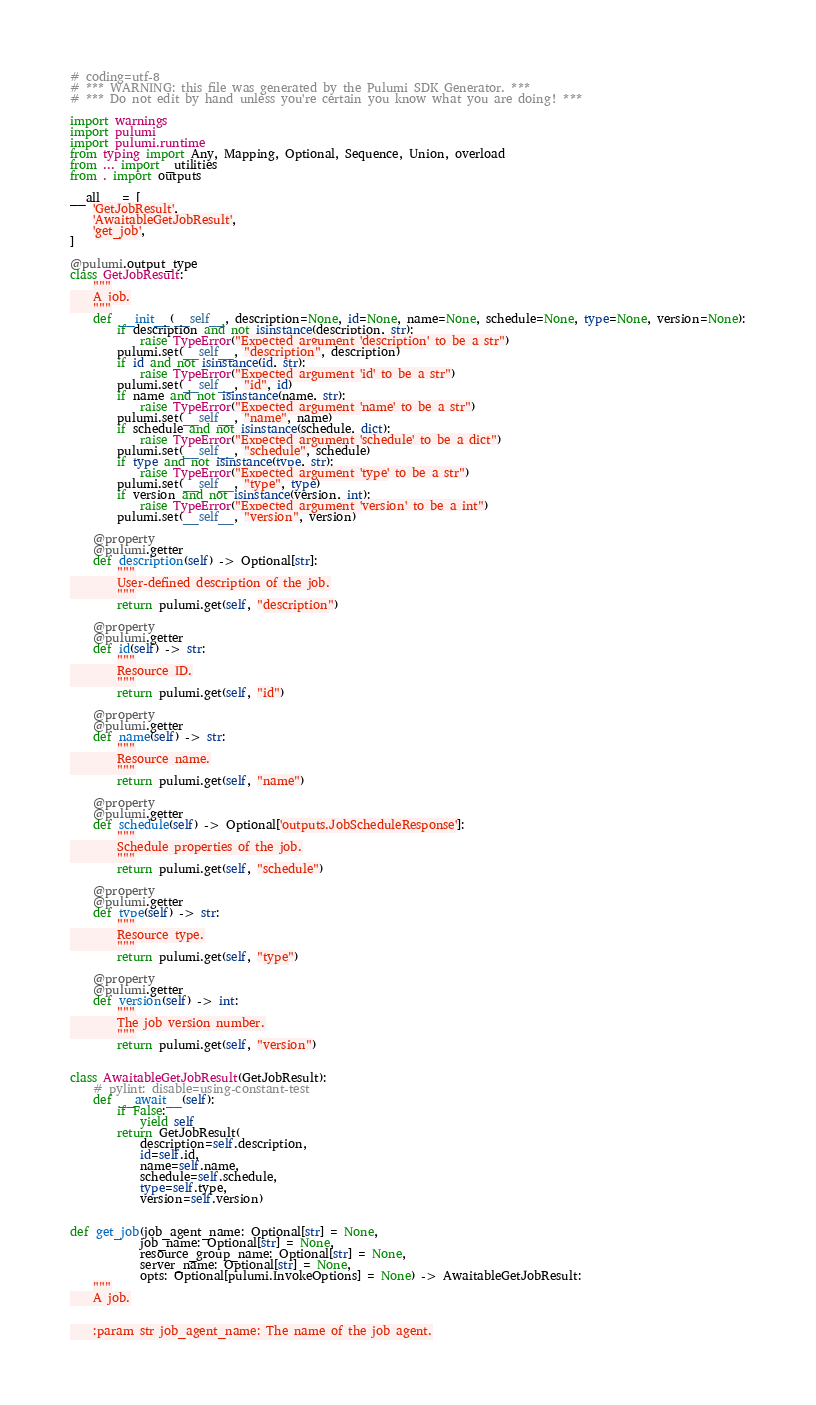Convert code to text. <code><loc_0><loc_0><loc_500><loc_500><_Python_># coding=utf-8
# *** WARNING: this file was generated by the Pulumi SDK Generator. ***
# *** Do not edit by hand unless you're certain you know what you are doing! ***

import warnings
import pulumi
import pulumi.runtime
from typing import Any, Mapping, Optional, Sequence, Union, overload
from ... import _utilities
from . import outputs

__all__ = [
    'GetJobResult',
    'AwaitableGetJobResult',
    'get_job',
]

@pulumi.output_type
class GetJobResult:
    """
    A job.
    """
    def __init__(__self__, description=None, id=None, name=None, schedule=None, type=None, version=None):
        if description and not isinstance(description, str):
            raise TypeError("Expected argument 'description' to be a str")
        pulumi.set(__self__, "description", description)
        if id and not isinstance(id, str):
            raise TypeError("Expected argument 'id' to be a str")
        pulumi.set(__self__, "id", id)
        if name and not isinstance(name, str):
            raise TypeError("Expected argument 'name' to be a str")
        pulumi.set(__self__, "name", name)
        if schedule and not isinstance(schedule, dict):
            raise TypeError("Expected argument 'schedule' to be a dict")
        pulumi.set(__self__, "schedule", schedule)
        if type and not isinstance(type, str):
            raise TypeError("Expected argument 'type' to be a str")
        pulumi.set(__self__, "type", type)
        if version and not isinstance(version, int):
            raise TypeError("Expected argument 'version' to be a int")
        pulumi.set(__self__, "version", version)

    @property
    @pulumi.getter
    def description(self) -> Optional[str]:
        """
        User-defined description of the job.
        """
        return pulumi.get(self, "description")

    @property
    @pulumi.getter
    def id(self) -> str:
        """
        Resource ID.
        """
        return pulumi.get(self, "id")

    @property
    @pulumi.getter
    def name(self) -> str:
        """
        Resource name.
        """
        return pulumi.get(self, "name")

    @property
    @pulumi.getter
    def schedule(self) -> Optional['outputs.JobScheduleResponse']:
        """
        Schedule properties of the job.
        """
        return pulumi.get(self, "schedule")

    @property
    @pulumi.getter
    def type(self) -> str:
        """
        Resource type.
        """
        return pulumi.get(self, "type")

    @property
    @pulumi.getter
    def version(self) -> int:
        """
        The job version number.
        """
        return pulumi.get(self, "version")


class AwaitableGetJobResult(GetJobResult):
    # pylint: disable=using-constant-test
    def __await__(self):
        if False:
            yield self
        return GetJobResult(
            description=self.description,
            id=self.id,
            name=self.name,
            schedule=self.schedule,
            type=self.type,
            version=self.version)


def get_job(job_agent_name: Optional[str] = None,
            job_name: Optional[str] = None,
            resource_group_name: Optional[str] = None,
            server_name: Optional[str] = None,
            opts: Optional[pulumi.InvokeOptions] = None) -> AwaitableGetJobResult:
    """
    A job.


    :param str job_agent_name: The name of the job agent.</code> 